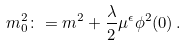<formula> <loc_0><loc_0><loc_500><loc_500>m _ { 0 } ^ { 2 } \colon = m ^ { 2 } + \frac { \lambda } { 2 } \mu ^ { \epsilon } \phi ^ { 2 } ( 0 ) \, .</formula> 